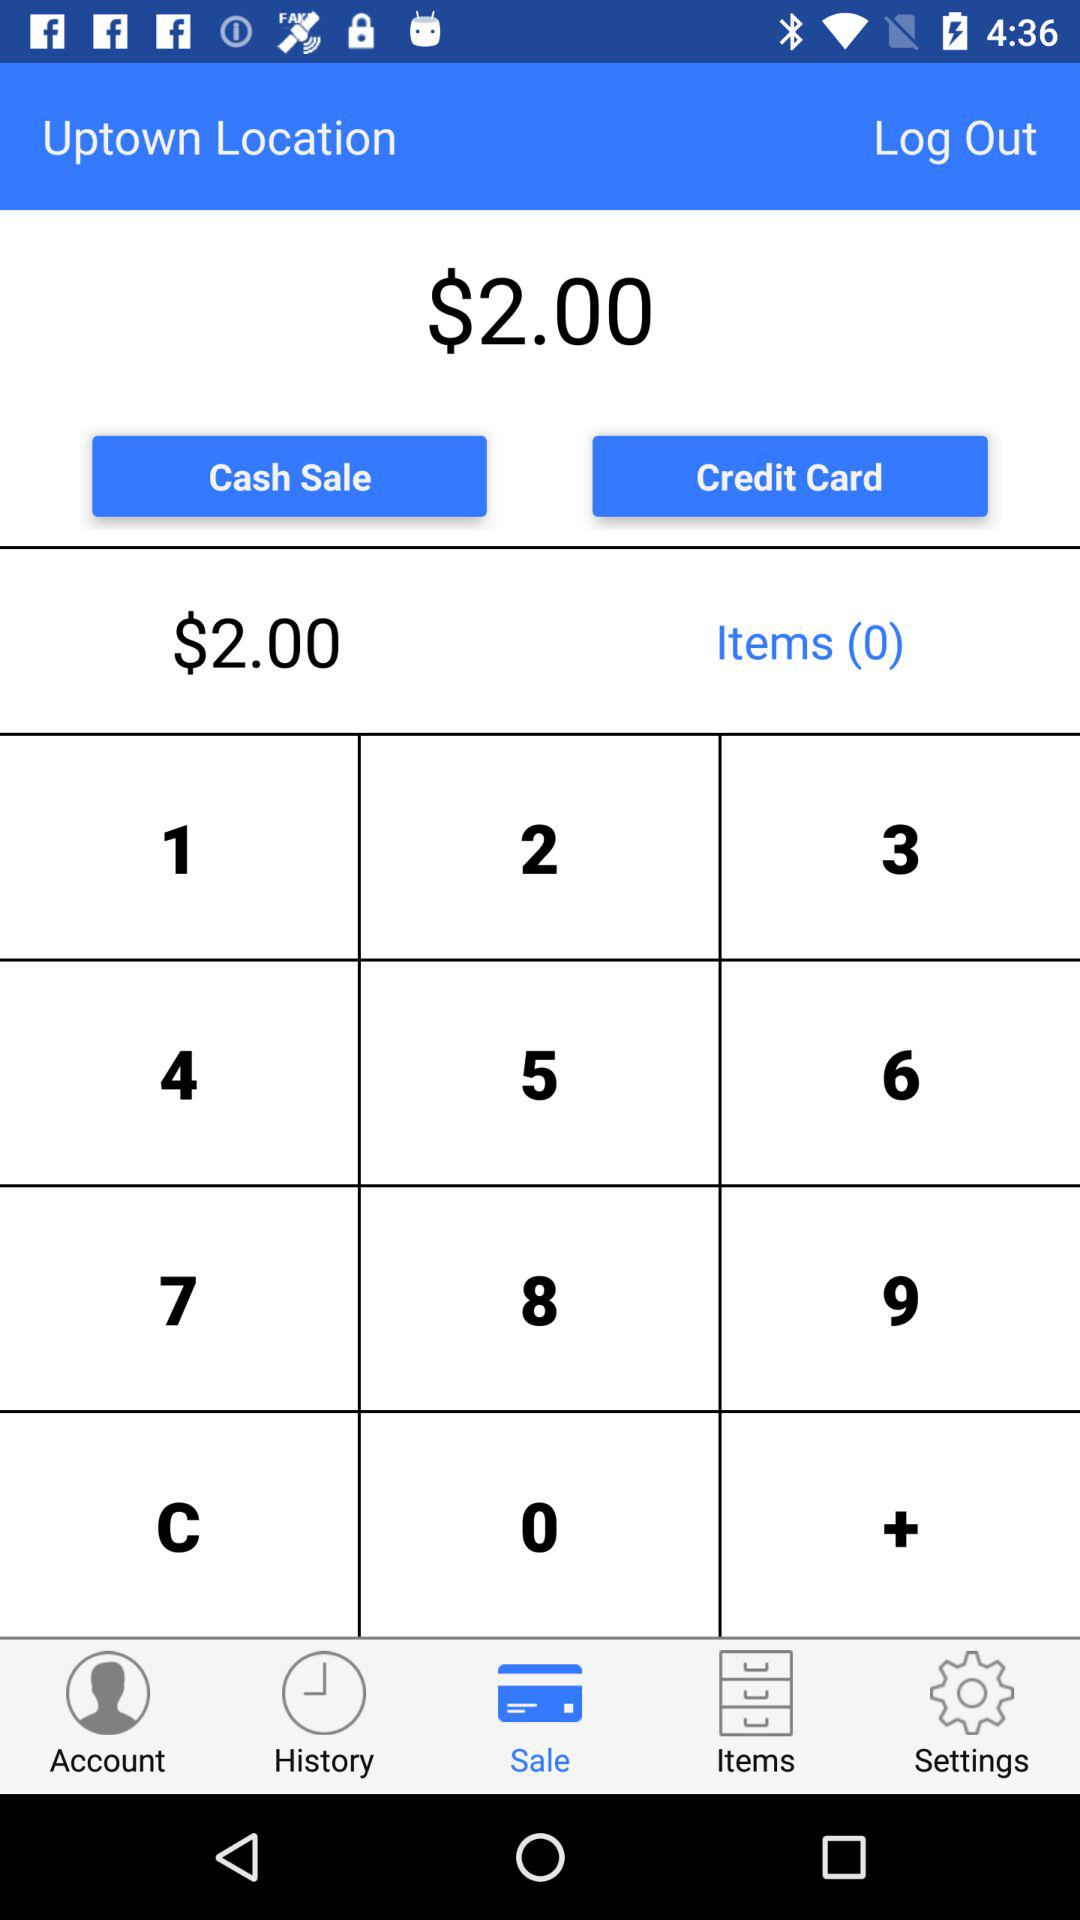How many dollars are in cash sale?
When the provided information is insufficient, respond with <no answer>. <no answer> 